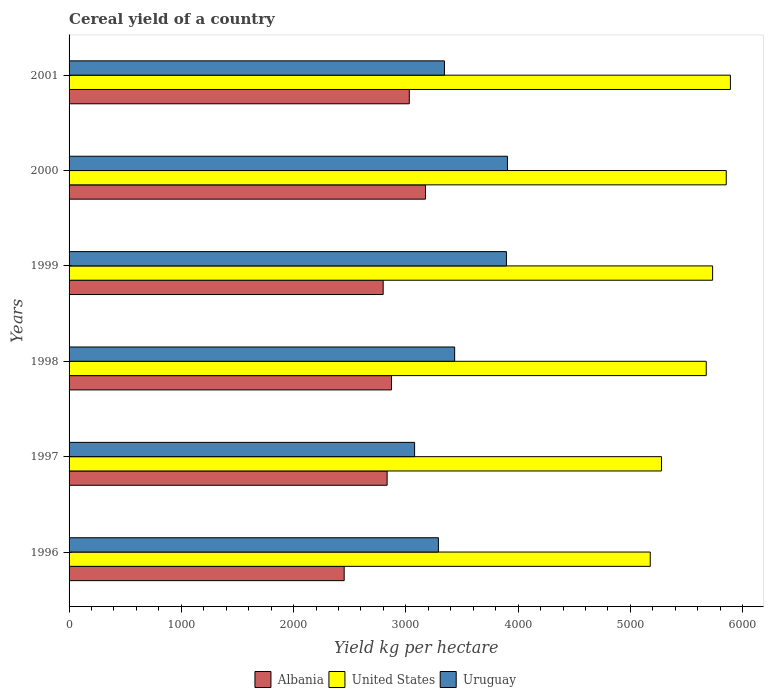How many different coloured bars are there?
Your answer should be very brief. 3. Are the number of bars on each tick of the Y-axis equal?
Your answer should be compact. Yes. How many bars are there on the 5th tick from the bottom?
Provide a short and direct response. 3. In how many cases, is the number of bars for a given year not equal to the number of legend labels?
Ensure brevity in your answer.  0. What is the total cereal yield in United States in 1996?
Keep it short and to the point. 5177.4. Across all years, what is the maximum total cereal yield in United States?
Ensure brevity in your answer.  5891.52. Across all years, what is the minimum total cereal yield in United States?
Your response must be concise. 5177.4. In which year was the total cereal yield in Albania maximum?
Your answer should be compact. 2000. What is the total total cereal yield in Albania in the graph?
Keep it short and to the point. 1.72e+04. What is the difference between the total cereal yield in Albania in 1997 and that in 2000?
Your response must be concise. -341.78. What is the difference between the total cereal yield in United States in 1996 and the total cereal yield in Uruguay in 2001?
Your answer should be compact. 1833.53. What is the average total cereal yield in United States per year?
Give a very brief answer. 5601.67. In the year 1996, what is the difference between the total cereal yield in United States and total cereal yield in Albania?
Provide a short and direct response. 2726.55. In how many years, is the total cereal yield in Albania greater than 1000 kg per hectare?
Your response must be concise. 6. What is the ratio of the total cereal yield in Albania in 1997 to that in 2001?
Your response must be concise. 0.93. Is the total cereal yield in Uruguay in 1999 less than that in 2000?
Your answer should be very brief. Yes. Is the difference between the total cereal yield in United States in 1999 and 2000 greater than the difference between the total cereal yield in Albania in 1999 and 2000?
Keep it short and to the point. Yes. What is the difference between the highest and the second highest total cereal yield in Uruguay?
Your response must be concise. 8.94. What is the difference between the highest and the lowest total cereal yield in Albania?
Your answer should be compact. 724.23. What does the 1st bar from the bottom in 2001 represents?
Provide a short and direct response. Albania. How many bars are there?
Offer a very short reply. 18. How many years are there in the graph?
Provide a succinct answer. 6. What is the difference between two consecutive major ticks on the X-axis?
Provide a succinct answer. 1000. Are the values on the major ticks of X-axis written in scientific E-notation?
Your answer should be compact. No. Does the graph contain any zero values?
Give a very brief answer. No. Does the graph contain grids?
Your answer should be compact. No. What is the title of the graph?
Give a very brief answer. Cereal yield of a country. Does "South Sudan" appear as one of the legend labels in the graph?
Ensure brevity in your answer.  No. What is the label or title of the X-axis?
Your response must be concise. Yield kg per hectare. What is the Yield kg per hectare of Albania in 1996?
Give a very brief answer. 2450.85. What is the Yield kg per hectare of United States in 1996?
Offer a terse response. 5177.4. What is the Yield kg per hectare in Uruguay in 1996?
Make the answer very short. 3290.14. What is the Yield kg per hectare in Albania in 1997?
Offer a terse response. 2833.3. What is the Yield kg per hectare of United States in 1997?
Offer a terse response. 5277.67. What is the Yield kg per hectare in Uruguay in 1997?
Provide a short and direct response. 3078.02. What is the Yield kg per hectare in Albania in 1998?
Make the answer very short. 2872.11. What is the Yield kg per hectare in United States in 1998?
Your answer should be compact. 5676.14. What is the Yield kg per hectare in Uruguay in 1998?
Offer a terse response. 3434.85. What is the Yield kg per hectare in Albania in 1999?
Your response must be concise. 2798.09. What is the Yield kg per hectare of United States in 1999?
Provide a succinct answer. 5732.99. What is the Yield kg per hectare in Uruguay in 1999?
Ensure brevity in your answer.  3896.24. What is the Yield kg per hectare of Albania in 2000?
Your answer should be very brief. 3175.08. What is the Yield kg per hectare of United States in 2000?
Offer a very short reply. 5854.28. What is the Yield kg per hectare of Uruguay in 2000?
Offer a very short reply. 3905.18. What is the Yield kg per hectare of Albania in 2001?
Offer a very short reply. 3030.76. What is the Yield kg per hectare of United States in 2001?
Give a very brief answer. 5891.52. What is the Yield kg per hectare of Uruguay in 2001?
Provide a succinct answer. 3343.86. Across all years, what is the maximum Yield kg per hectare in Albania?
Offer a very short reply. 3175.08. Across all years, what is the maximum Yield kg per hectare in United States?
Give a very brief answer. 5891.52. Across all years, what is the maximum Yield kg per hectare in Uruguay?
Your response must be concise. 3905.18. Across all years, what is the minimum Yield kg per hectare of Albania?
Your response must be concise. 2450.85. Across all years, what is the minimum Yield kg per hectare of United States?
Your answer should be compact. 5177.4. Across all years, what is the minimum Yield kg per hectare in Uruguay?
Give a very brief answer. 3078.02. What is the total Yield kg per hectare of Albania in the graph?
Provide a succinct answer. 1.72e+04. What is the total Yield kg per hectare of United States in the graph?
Provide a succinct answer. 3.36e+04. What is the total Yield kg per hectare in Uruguay in the graph?
Keep it short and to the point. 2.09e+04. What is the difference between the Yield kg per hectare of Albania in 1996 and that in 1997?
Provide a short and direct response. -382.45. What is the difference between the Yield kg per hectare in United States in 1996 and that in 1997?
Provide a succinct answer. -100.27. What is the difference between the Yield kg per hectare of Uruguay in 1996 and that in 1997?
Offer a terse response. 212.13. What is the difference between the Yield kg per hectare of Albania in 1996 and that in 1998?
Keep it short and to the point. -421.26. What is the difference between the Yield kg per hectare in United States in 1996 and that in 1998?
Provide a short and direct response. -498.74. What is the difference between the Yield kg per hectare of Uruguay in 1996 and that in 1998?
Give a very brief answer. -144.71. What is the difference between the Yield kg per hectare of Albania in 1996 and that in 1999?
Provide a short and direct response. -347.24. What is the difference between the Yield kg per hectare in United States in 1996 and that in 1999?
Your response must be concise. -555.59. What is the difference between the Yield kg per hectare in Uruguay in 1996 and that in 1999?
Keep it short and to the point. -606.1. What is the difference between the Yield kg per hectare in Albania in 1996 and that in 2000?
Give a very brief answer. -724.23. What is the difference between the Yield kg per hectare of United States in 1996 and that in 2000?
Your response must be concise. -676.88. What is the difference between the Yield kg per hectare of Uruguay in 1996 and that in 2000?
Provide a succinct answer. -615.03. What is the difference between the Yield kg per hectare in Albania in 1996 and that in 2001?
Keep it short and to the point. -579.91. What is the difference between the Yield kg per hectare in United States in 1996 and that in 2001?
Your response must be concise. -714.12. What is the difference between the Yield kg per hectare of Uruguay in 1996 and that in 2001?
Make the answer very short. -53.72. What is the difference between the Yield kg per hectare in Albania in 1997 and that in 1998?
Make the answer very short. -38.81. What is the difference between the Yield kg per hectare of United States in 1997 and that in 1998?
Your response must be concise. -398.47. What is the difference between the Yield kg per hectare of Uruguay in 1997 and that in 1998?
Ensure brevity in your answer.  -356.83. What is the difference between the Yield kg per hectare in Albania in 1997 and that in 1999?
Provide a succinct answer. 35.22. What is the difference between the Yield kg per hectare in United States in 1997 and that in 1999?
Offer a very short reply. -455.32. What is the difference between the Yield kg per hectare of Uruguay in 1997 and that in 1999?
Your response must be concise. -818.23. What is the difference between the Yield kg per hectare in Albania in 1997 and that in 2000?
Ensure brevity in your answer.  -341.78. What is the difference between the Yield kg per hectare of United States in 1997 and that in 2000?
Give a very brief answer. -576.61. What is the difference between the Yield kg per hectare in Uruguay in 1997 and that in 2000?
Ensure brevity in your answer.  -827.16. What is the difference between the Yield kg per hectare of Albania in 1997 and that in 2001?
Your answer should be compact. -197.46. What is the difference between the Yield kg per hectare in United States in 1997 and that in 2001?
Make the answer very short. -613.85. What is the difference between the Yield kg per hectare in Uruguay in 1997 and that in 2001?
Provide a short and direct response. -265.85. What is the difference between the Yield kg per hectare in Albania in 1998 and that in 1999?
Offer a terse response. 74.03. What is the difference between the Yield kg per hectare of United States in 1998 and that in 1999?
Give a very brief answer. -56.85. What is the difference between the Yield kg per hectare in Uruguay in 1998 and that in 1999?
Offer a very short reply. -461.39. What is the difference between the Yield kg per hectare of Albania in 1998 and that in 2000?
Make the answer very short. -302.97. What is the difference between the Yield kg per hectare in United States in 1998 and that in 2000?
Offer a very short reply. -178.15. What is the difference between the Yield kg per hectare in Uruguay in 1998 and that in 2000?
Provide a short and direct response. -470.33. What is the difference between the Yield kg per hectare in Albania in 1998 and that in 2001?
Your answer should be compact. -158.65. What is the difference between the Yield kg per hectare in United States in 1998 and that in 2001?
Make the answer very short. -215.38. What is the difference between the Yield kg per hectare of Uruguay in 1998 and that in 2001?
Make the answer very short. 90.99. What is the difference between the Yield kg per hectare of Albania in 1999 and that in 2000?
Provide a short and direct response. -377. What is the difference between the Yield kg per hectare of United States in 1999 and that in 2000?
Your answer should be compact. -121.3. What is the difference between the Yield kg per hectare of Uruguay in 1999 and that in 2000?
Give a very brief answer. -8.94. What is the difference between the Yield kg per hectare of Albania in 1999 and that in 2001?
Your response must be concise. -232.67. What is the difference between the Yield kg per hectare in United States in 1999 and that in 2001?
Give a very brief answer. -158.53. What is the difference between the Yield kg per hectare of Uruguay in 1999 and that in 2001?
Your response must be concise. 552.38. What is the difference between the Yield kg per hectare of Albania in 2000 and that in 2001?
Your answer should be very brief. 144.32. What is the difference between the Yield kg per hectare in United States in 2000 and that in 2001?
Offer a very short reply. -37.24. What is the difference between the Yield kg per hectare in Uruguay in 2000 and that in 2001?
Give a very brief answer. 561.32. What is the difference between the Yield kg per hectare in Albania in 1996 and the Yield kg per hectare in United States in 1997?
Make the answer very short. -2826.82. What is the difference between the Yield kg per hectare of Albania in 1996 and the Yield kg per hectare of Uruguay in 1997?
Provide a succinct answer. -627.17. What is the difference between the Yield kg per hectare of United States in 1996 and the Yield kg per hectare of Uruguay in 1997?
Provide a short and direct response. 2099.38. What is the difference between the Yield kg per hectare of Albania in 1996 and the Yield kg per hectare of United States in 1998?
Provide a short and direct response. -3225.28. What is the difference between the Yield kg per hectare in Albania in 1996 and the Yield kg per hectare in Uruguay in 1998?
Offer a terse response. -984. What is the difference between the Yield kg per hectare in United States in 1996 and the Yield kg per hectare in Uruguay in 1998?
Offer a very short reply. 1742.55. What is the difference between the Yield kg per hectare in Albania in 1996 and the Yield kg per hectare in United States in 1999?
Give a very brief answer. -3282.13. What is the difference between the Yield kg per hectare in Albania in 1996 and the Yield kg per hectare in Uruguay in 1999?
Your answer should be very brief. -1445.39. What is the difference between the Yield kg per hectare in United States in 1996 and the Yield kg per hectare in Uruguay in 1999?
Your answer should be very brief. 1281.16. What is the difference between the Yield kg per hectare of Albania in 1996 and the Yield kg per hectare of United States in 2000?
Your response must be concise. -3403.43. What is the difference between the Yield kg per hectare in Albania in 1996 and the Yield kg per hectare in Uruguay in 2000?
Offer a terse response. -1454.33. What is the difference between the Yield kg per hectare in United States in 1996 and the Yield kg per hectare in Uruguay in 2000?
Make the answer very short. 1272.22. What is the difference between the Yield kg per hectare of Albania in 1996 and the Yield kg per hectare of United States in 2001?
Offer a terse response. -3440.67. What is the difference between the Yield kg per hectare of Albania in 1996 and the Yield kg per hectare of Uruguay in 2001?
Provide a short and direct response. -893.01. What is the difference between the Yield kg per hectare of United States in 1996 and the Yield kg per hectare of Uruguay in 2001?
Your response must be concise. 1833.54. What is the difference between the Yield kg per hectare of Albania in 1997 and the Yield kg per hectare of United States in 1998?
Provide a short and direct response. -2842.83. What is the difference between the Yield kg per hectare of Albania in 1997 and the Yield kg per hectare of Uruguay in 1998?
Your answer should be very brief. -601.55. What is the difference between the Yield kg per hectare in United States in 1997 and the Yield kg per hectare in Uruguay in 1998?
Your response must be concise. 1842.82. What is the difference between the Yield kg per hectare of Albania in 1997 and the Yield kg per hectare of United States in 1999?
Give a very brief answer. -2899.68. What is the difference between the Yield kg per hectare of Albania in 1997 and the Yield kg per hectare of Uruguay in 1999?
Give a very brief answer. -1062.94. What is the difference between the Yield kg per hectare in United States in 1997 and the Yield kg per hectare in Uruguay in 1999?
Make the answer very short. 1381.42. What is the difference between the Yield kg per hectare of Albania in 1997 and the Yield kg per hectare of United States in 2000?
Offer a terse response. -3020.98. What is the difference between the Yield kg per hectare in Albania in 1997 and the Yield kg per hectare in Uruguay in 2000?
Your answer should be very brief. -1071.88. What is the difference between the Yield kg per hectare in United States in 1997 and the Yield kg per hectare in Uruguay in 2000?
Your response must be concise. 1372.49. What is the difference between the Yield kg per hectare of Albania in 1997 and the Yield kg per hectare of United States in 2001?
Provide a succinct answer. -3058.22. What is the difference between the Yield kg per hectare of Albania in 1997 and the Yield kg per hectare of Uruguay in 2001?
Your response must be concise. -510.56. What is the difference between the Yield kg per hectare of United States in 1997 and the Yield kg per hectare of Uruguay in 2001?
Your response must be concise. 1933.8. What is the difference between the Yield kg per hectare of Albania in 1998 and the Yield kg per hectare of United States in 1999?
Ensure brevity in your answer.  -2860.87. What is the difference between the Yield kg per hectare of Albania in 1998 and the Yield kg per hectare of Uruguay in 1999?
Offer a terse response. -1024.13. What is the difference between the Yield kg per hectare of United States in 1998 and the Yield kg per hectare of Uruguay in 1999?
Give a very brief answer. 1779.89. What is the difference between the Yield kg per hectare in Albania in 1998 and the Yield kg per hectare in United States in 2000?
Offer a very short reply. -2982.17. What is the difference between the Yield kg per hectare of Albania in 1998 and the Yield kg per hectare of Uruguay in 2000?
Your answer should be compact. -1033.07. What is the difference between the Yield kg per hectare of United States in 1998 and the Yield kg per hectare of Uruguay in 2000?
Ensure brevity in your answer.  1770.96. What is the difference between the Yield kg per hectare in Albania in 1998 and the Yield kg per hectare in United States in 2001?
Your response must be concise. -3019.41. What is the difference between the Yield kg per hectare in Albania in 1998 and the Yield kg per hectare in Uruguay in 2001?
Make the answer very short. -471.75. What is the difference between the Yield kg per hectare of United States in 1998 and the Yield kg per hectare of Uruguay in 2001?
Provide a short and direct response. 2332.27. What is the difference between the Yield kg per hectare in Albania in 1999 and the Yield kg per hectare in United States in 2000?
Make the answer very short. -3056.19. What is the difference between the Yield kg per hectare of Albania in 1999 and the Yield kg per hectare of Uruguay in 2000?
Provide a short and direct response. -1107.09. What is the difference between the Yield kg per hectare in United States in 1999 and the Yield kg per hectare in Uruguay in 2000?
Your answer should be very brief. 1827.81. What is the difference between the Yield kg per hectare in Albania in 1999 and the Yield kg per hectare in United States in 2001?
Offer a very short reply. -3093.43. What is the difference between the Yield kg per hectare in Albania in 1999 and the Yield kg per hectare in Uruguay in 2001?
Provide a succinct answer. -545.78. What is the difference between the Yield kg per hectare of United States in 1999 and the Yield kg per hectare of Uruguay in 2001?
Offer a very short reply. 2389.12. What is the difference between the Yield kg per hectare of Albania in 2000 and the Yield kg per hectare of United States in 2001?
Offer a terse response. -2716.44. What is the difference between the Yield kg per hectare in Albania in 2000 and the Yield kg per hectare in Uruguay in 2001?
Offer a very short reply. -168.78. What is the difference between the Yield kg per hectare in United States in 2000 and the Yield kg per hectare in Uruguay in 2001?
Provide a succinct answer. 2510.42. What is the average Yield kg per hectare in Albania per year?
Your answer should be very brief. 2860.03. What is the average Yield kg per hectare of United States per year?
Keep it short and to the point. 5601.67. What is the average Yield kg per hectare of Uruguay per year?
Make the answer very short. 3491.38. In the year 1996, what is the difference between the Yield kg per hectare of Albania and Yield kg per hectare of United States?
Your answer should be compact. -2726.55. In the year 1996, what is the difference between the Yield kg per hectare of Albania and Yield kg per hectare of Uruguay?
Give a very brief answer. -839.29. In the year 1996, what is the difference between the Yield kg per hectare of United States and Yield kg per hectare of Uruguay?
Offer a very short reply. 1887.26. In the year 1997, what is the difference between the Yield kg per hectare in Albania and Yield kg per hectare in United States?
Ensure brevity in your answer.  -2444.36. In the year 1997, what is the difference between the Yield kg per hectare in Albania and Yield kg per hectare in Uruguay?
Make the answer very short. -244.72. In the year 1997, what is the difference between the Yield kg per hectare in United States and Yield kg per hectare in Uruguay?
Provide a succinct answer. 2199.65. In the year 1998, what is the difference between the Yield kg per hectare of Albania and Yield kg per hectare of United States?
Keep it short and to the point. -2804.02. In the year 1998, what is the difference between the Yield kg per hectare of Albania and Yield kg per hectare of Uruguay?
Make the answer very short. -562.74. In the year 1998, what is the difference between the Yield kg per hectare in United States and Yield kg per hectare in Uruguay?
Ensure brevity in your answer.  2241.28. In the year 1999, what is the difference between the Yield kg per hectare in Albania and Yield kg per hectare in United States?
Give a very brief answer. -2934.9. In the year 1999, what is the difference between the Yield kg per hectare of Albania and Yield kg per hectare of Uruguay?
Your answer should be very brief. -1098.16. In the year 1999, what is the difference between the Yield kg per hectare in United States and Yield kg per hectare in Uruguay?
Give a very brief answer. 1836.74. In the year 2000, what is the difference between the Yield kg per hectare of Albania and Yield kg per hectare of United States?
Ensure brevity in your answer.  -2679.2. In the year 2000, what is the difference between the Yield kg per hectare of Albania and Yield kg per hectare of Uruguay?
Your answer should be very brief. -730.1. In the year 2000, what is the difference between the Yield kg per hectare of United States and Yield kg per hectare of Uruguay?
Your answer should be compact. 1949.1. In the year 2001, what is the difference between the Yield kg per hectare in Albania and Yield kg per hectare in United States?
Keep it short and to the point. -2860.76. In the year 2001, what is the difference between the Yield kg per hectare of Albania and Yield kg per hectare of Uruguay?
Offer a very short reply. -313.11. In the year 2001, what is the difference between the Yield kg per hectare of United States and Yield kg per hectare of Uruguay?
Provide a succinct answer. 2547.66. What is the ratio of the Yield kg per hectare in Albania in 1996 to that in 1997?
Offer a terse response. 0.86. What is the ratio of the Yield kg per hectare of Uruguay in 1996 to that in 1997?
Provide a succinct answer. 1.07. What is the ratio of the Yield kg per hectare in Albania in 1996 to that in 1998?
Offer a very short reply. 0.85. What is the ratio of the Yield kg per hectare of United States in 1996 to that in 1998?
Offer a terse response. 0.91. What is the ratio of the Yield kg per hectare of Uruguay in 1996 to that in 1998?
Give a very brief answer. 0.96. What is the ratio of the Yield kg per hectare in Albania in 1996 to that in 1999?
Your answer should be compact. 0.88. What is the ratio of the Yield kg per hectare in United States in 1996 to that in 1999?
Ensure brevity in your answer.  0.9. What is the ratio of the Yield kg per hectare of Uruguay in 1996 to that in 1999?
Give a very brief answer. 0.84. What is the ratio of the Yield kg per hectare in Albania in 1996 to that in 2000?
Your answer should be compact. 0.77. What is the ratio of the Yield kg per hectare in United States in 1996 to that in 2000?
Your answer should be very brief. 0.88. What is the ratio of the Yield kg per hectare in Uruguay in 1996 to that in 2000?
Keep it short and to the point. 0.84. What is the ratio of the Yield kg per hectare in Albania in 1996 to that in 2001?
Keep it short and to the point. 0.81. What is the ratio of the Yield kg per hectare of United States in 1996 to that in 2001?
Your answer should be compact. 0.88. What is the ratio of the Yield kg per hectare of Uruguay in 1996 to that in 2001?
Provide a succinct answer. 0.98. What is the ratio of the Yield kg per hectare of Albania in 1997 to that in 1998?
Your response must be concise. 0.99. What is the ratio of the Yield kg per hectare in United States in 1997 to that in 1998?
Provide a short and direct response. 0.93. What is the ratio of the Yield kg per hectare in Uruguay in 1997 to that in 1998?
Your response must be concise. 0.9. What is the ratio of the Yield kg per hectare of Albania in 1997 to that in 1999?
Offer a terse response. 1.01. What is the ratio of the Yield kg per hectare in United States in 1997 to that in 1999?
Offer a terse response. 0.92. What is the ratio of the Yield kg per hectare in Uruguay in 1997 to that in 1999?
Your response must be concise. 0.79. What is the ratio of the Yield kg per hectare in Albania in 1997 to that in 2000?
Offer a terse response. 0.89. What is the ratio of the Yield kg per hectare of United States in 1997 to that in 2000?
Offer a terse response. 0.9. What is the ratio of the Yield kg per hectare in Uruguay in 1997 to that in 2000?
Your answer should be compact. 0.79. What is the ratio of the Yield kg per hectare in Albania in 1997 to that in 2001?
Your answer should be compact. 0.93. What is the ratio of the Yield kg per hectare of United States in 1997 to that in 2001?
Provide a short and direct response. 0.9. What is the ratio of the Yield kg per hectare in Uruguay in 1997 to that in 2001?
Ensure brevity in your answer.  0.92. What is the ratio of the Yield kg per hectare in Albania in 1998 to that in 1999?
Offer a very short reply. 1.03. What is the ratio of the Yield kg per hectare of Uruguay in 1998 to that in 1999?
Ensure brevity in your answer.  0.88. What is the ratio of the Yield kg per hectare in Albania in 1998 to that in 2000?
Your answer should be very brief. 0.9. What is the ratio of the Yield kg per hectare of United States in 1998 to that in 2000?
Provide a succinct answer. 0.97. What is the ratio of the Yield kg per hectare in Uruguay in 1998 to that in 2000?
Your response must be concise. 0.88. What is the ratio of the Yield kg per hectare in Albania in 1998 to that in 2001?
Your response must be concise. 0.95. What is the ratio of the Yield kg per hectare of United States in 1998 to that in 2001?
Keep it short and to the point. 0.96. What is the ratio of the Yield kg per hectare in Uruguay in 1998 to that in 2001?
Make the answer very short. 1.03. What is the ratio of the Yield kg per hectare in Albania in 1999 to that in 2000?
Offer a very short reply. 0.88. What is the ratio of the Yield kg per hectare of United States in 1999 to that in 2000?
Provide a short and direct response. 0.98. What is the ratio of the Yield kg per hectare in Albania in 1999 to that in 2001?
Ensure brevity in your answer.  0.92. What is the ratio of the Yield kg per hectare of United States in 1999 to that in 2001?
Provide a succinct answer. 0.97. What is the ratio of the Yield kg per hectare of Uruguay in 1999 to that in 2001?
Keep it short and to the point. 1.17. What is the ratio of the Yield kg per hectare of Albania in 2000 to that in 2001?
Provide a short and direct response. 1.05. What is the ratio of the Yield kg per hectare in United States in 2000 to that in 2001?
Provide a succinct answer. 0.99. What is the ratio of the Yield kg per hectare in Uruguay in 2000 to that in 2001?
Offer a very short reply. 1.17. What is the difference between the highest and the second highest Yield kg per hectare in Albania?
Give a very brief answer. 144.32. What is the difference between the highest and the second highest Yield kg per hectare of United States?
Make the answer very short. 37.24. What is the difference between the highest and the second highest Yield kg per hectare of Uruguay?
Provide a succinct answer. 8.94. What is the difference between the highest and the lowest Yield kg per hectare in Albania?
Offer a very short reply. 724.23. What is the difference between the highest and the lowest Yield kg per hectare of United States?
Offer a very short reply. 714.12. What is the difference between the highest and the lowest Yield kg per hectare in Uruguay?
Ensure brevity in your answer.  827.16. 